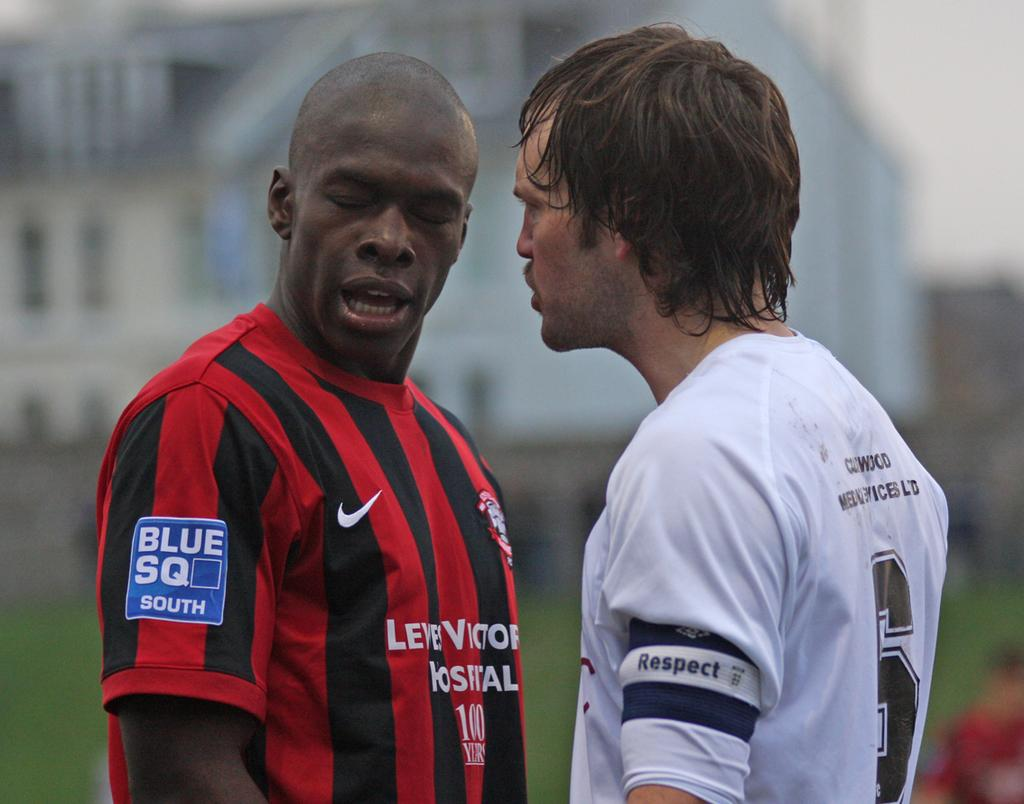<image>
Present a compact description of the photo's key features. A man in a white jersey has the word respect on the sleeve. 